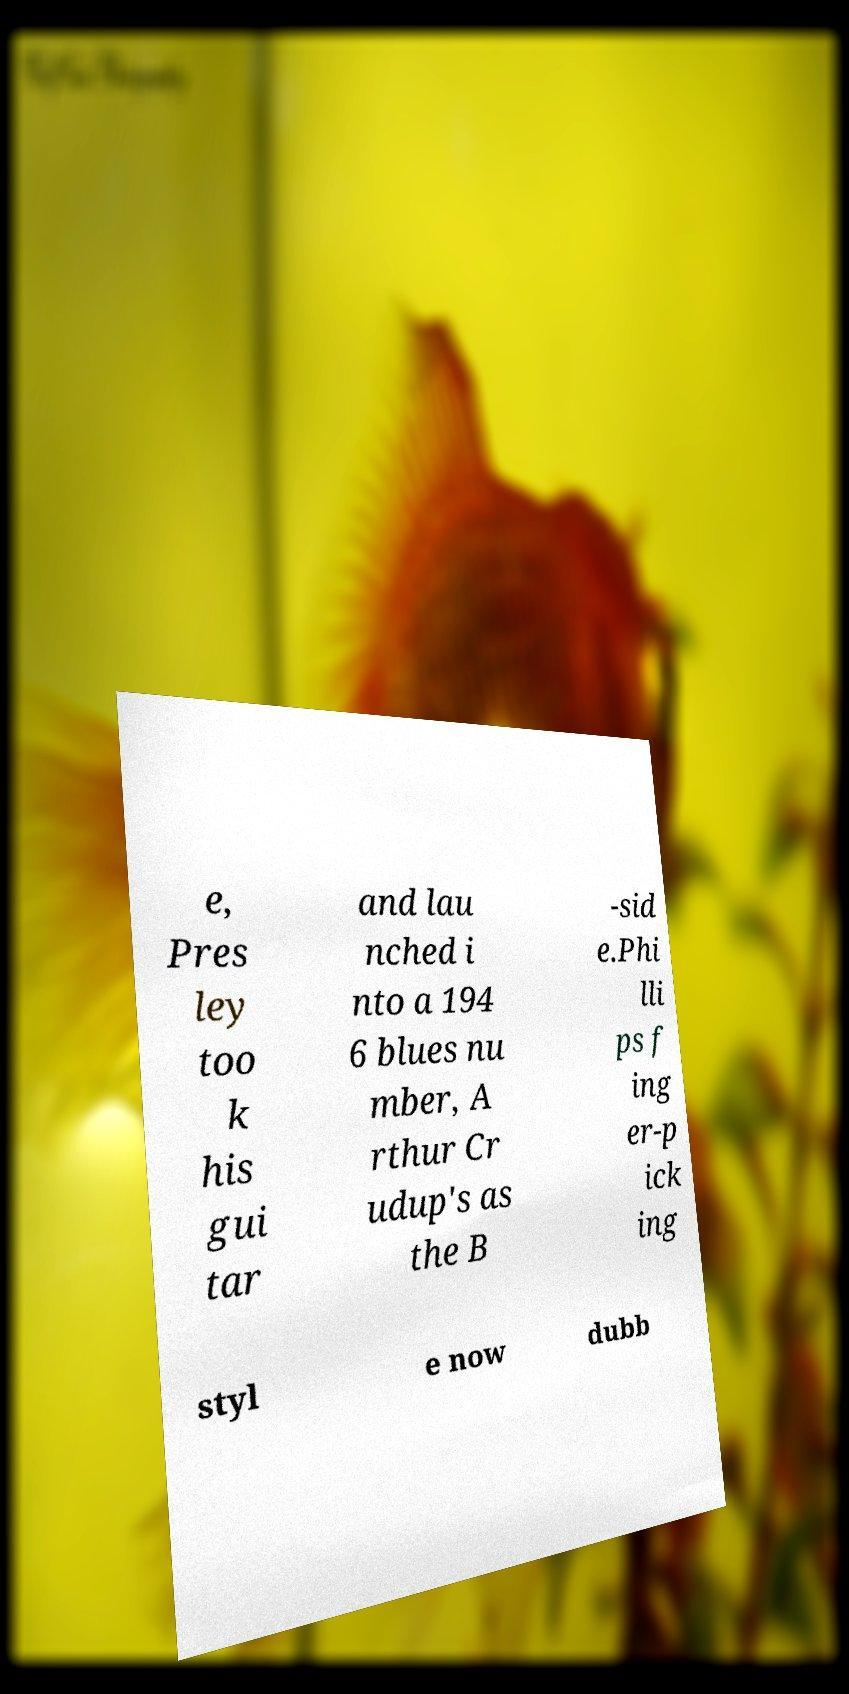Can you read and provide the text displayed in the image?This photo seems to have some interesting text. Can you extract and type it out for me? e, Pres ley too k his gui tar and lau nched i nto a 194 6 blues nu mber, A rthur Cr udup's as the B -sid e.Phi lli ps f ing er-p ick ing styl e now dubb 